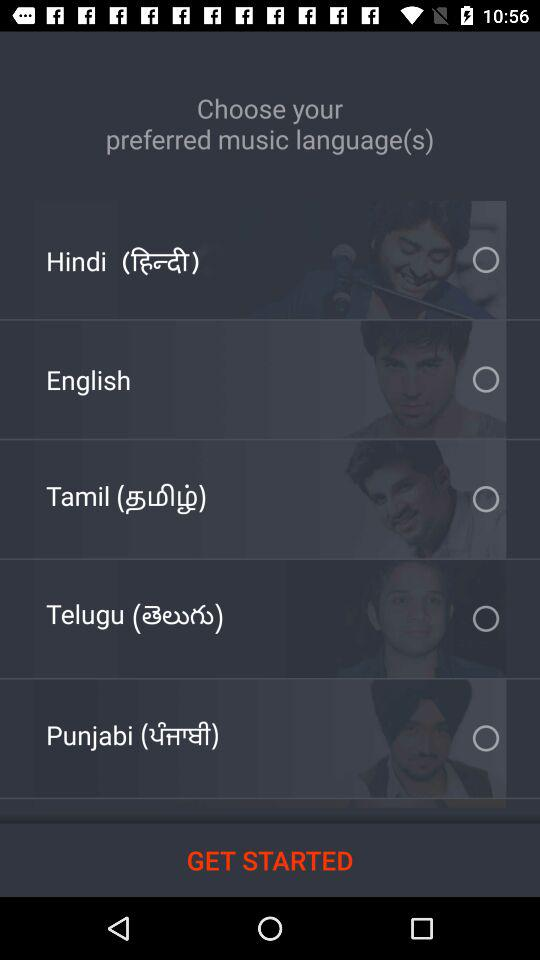How many languages are available to choose from?
Answer the question using a single word or phrase. 5 